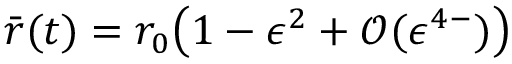Convert formula to latex. <formula><loc_0><loc_0><loc_500><loc_500>\bar { r } ( t ) = r _ { 0 } \left ( 1 - \epsilon ^ { 2 } + \mathcal { O } ( \epsilon ^ { 4 - } ) \right )</formula> 